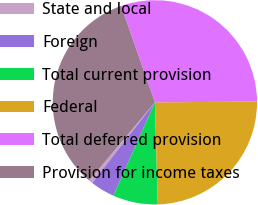Convert chart. <chart><loc_0><loc_0><loc_500><loc_500><pie_chart><fcel>State and local<fcel>Foreign<fcel>Total current provision<fcel>Federal<fcel>Total deferred provision<fcel>Provision for income taxes<nl><fcel>0.6%<fcel>3.86%<fcel>7.11%<fcel>24.66%<fcel>30.25%<fcel>33.51%<nl></chart> 